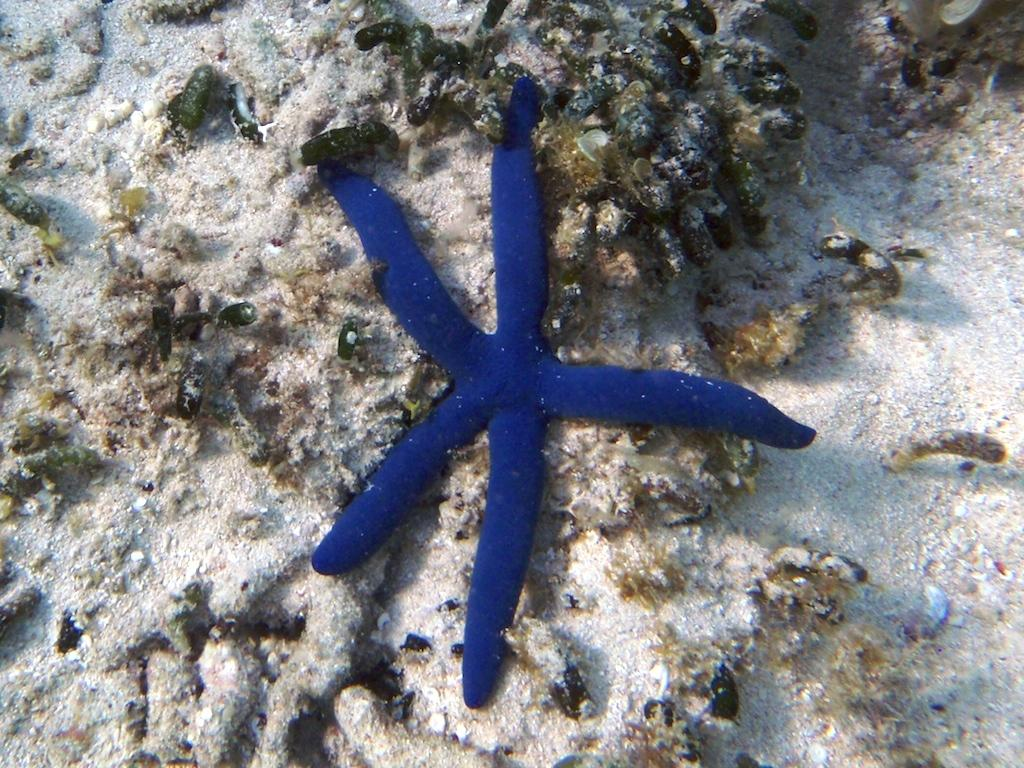What type of marine animal is present in the image? There is a blue starfish in the image. What other underwater features can be seen in the image? There is a group of coral reefs visible in the image. Where is the nest of the starfish located in the image? There is no nest present in the image, as starfish do not build nests. 